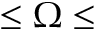Convert formula to latex. <formula><loc_0><loc_0><loc_500><loc_500>\leq \Omega \leq</formula> 